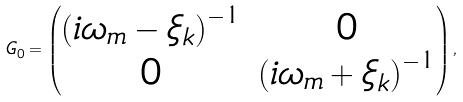Convert formula to latex. <formula><loc_0><loc_0><loc_500><loc_500>G _ { 0 } = \begin{pmatrix} \left ( i \omega _ { m } - \xi _ { k } \right ) ^ { - 1 } & 0 \\ 0 & \left ( i \omega _ { m } + \xi _ { k } \right ) ^ { - 1 } \end{pmatrix} ,</formula> 